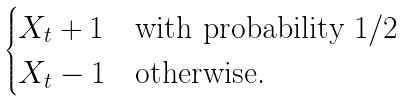Convert formula to latex. <formula><loc_0><loc_0><loc_500><loc_500>\begin{cases} X _ { t } + 1 & \text {with probability } 1 / 2 \\ X _ { t } - 1 & \text {otherwise.} \end{cases}</formula> 